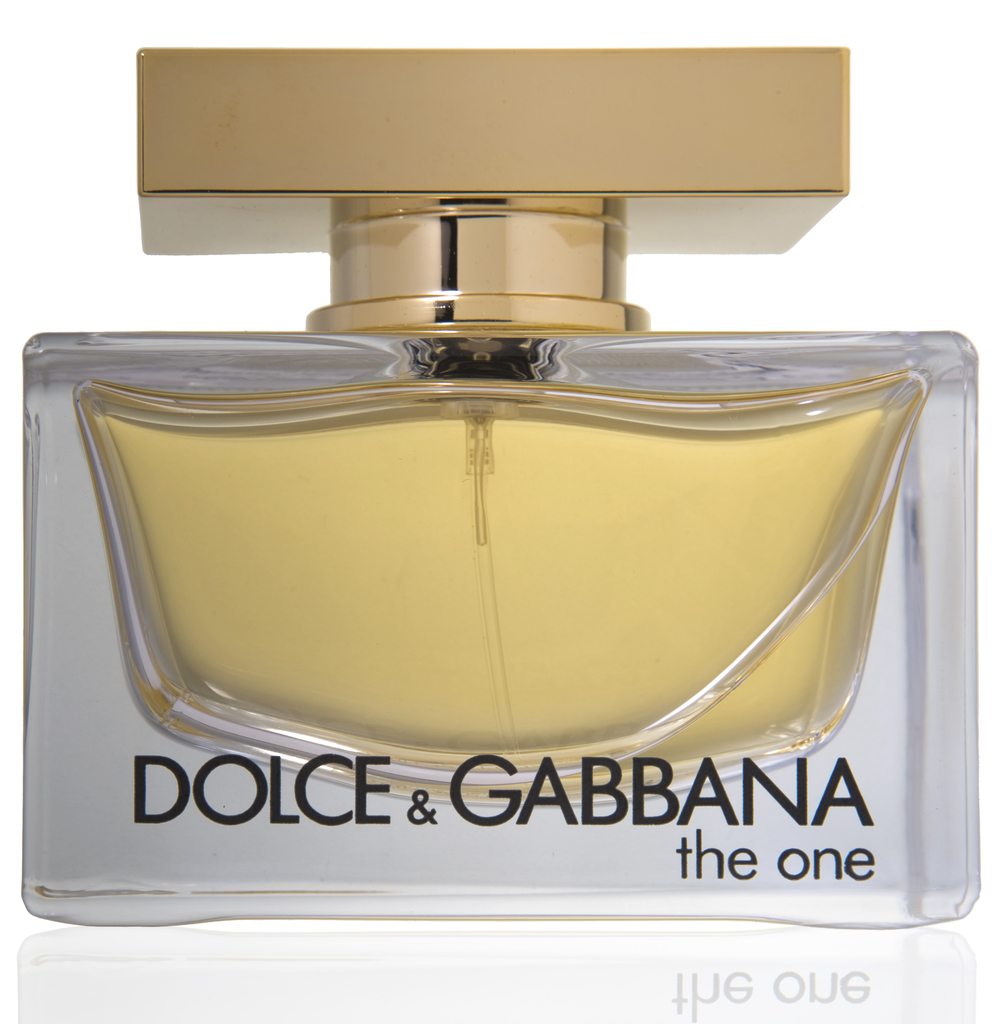What does the design of the perfume bottle say about the brand? The design of the perfume bottle reflects the brand's commitment to luxury and elegance. Dolce & Gabbana's choice of a clear, rectangular bottle with a golden cap and minimalistic labeling emphasizes a modern, sophisticated aesthetic that is both bold and timeless. This suggests that the brand values high-quality craftsmanship and classic style, aiming to offer consumers a sense of exclusivity and high fashion. 